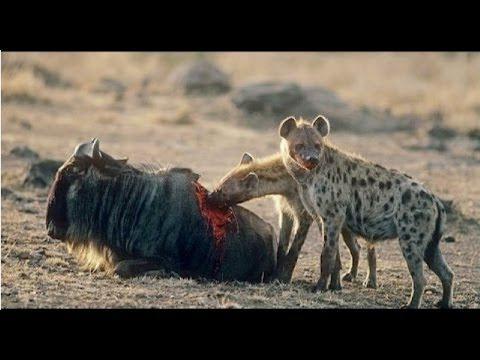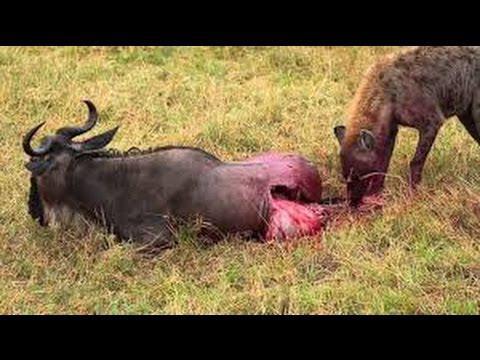The first image is the image on the left, the second image is the image on the right. For the images displayed, is the sentence "an animal is being eaten on the left pic" factually correct? Answer yes or no. Yes. The first image is the image on the left, the second image is the image on the right. Examine the images to the left and right. Is the description "Hyenas are circling their prey, which is still up on all 4 legs in both images." accurate? Answer yes or no. No. 